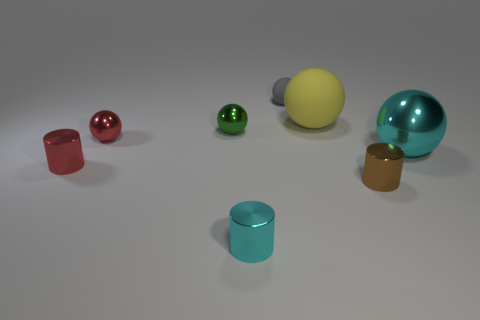What shape is the tiny cyan object? The tiny cyan object presents as a geometrical cylinder with smooth, circular ends and a long, straight side. 